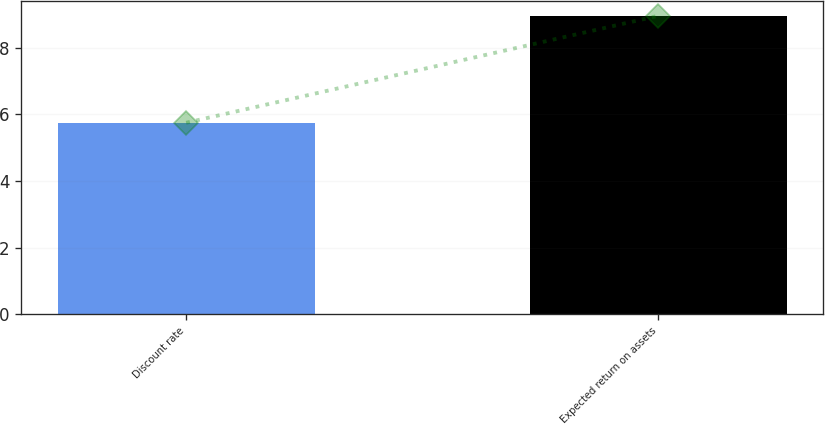<chart> <loc_0><loc_0><loc_500><loc_500><bar_chart><fcel>Discount rate<fcel>Expected return on assets<nl><fcel>5.75<fcel>8.96<nl></chart> 